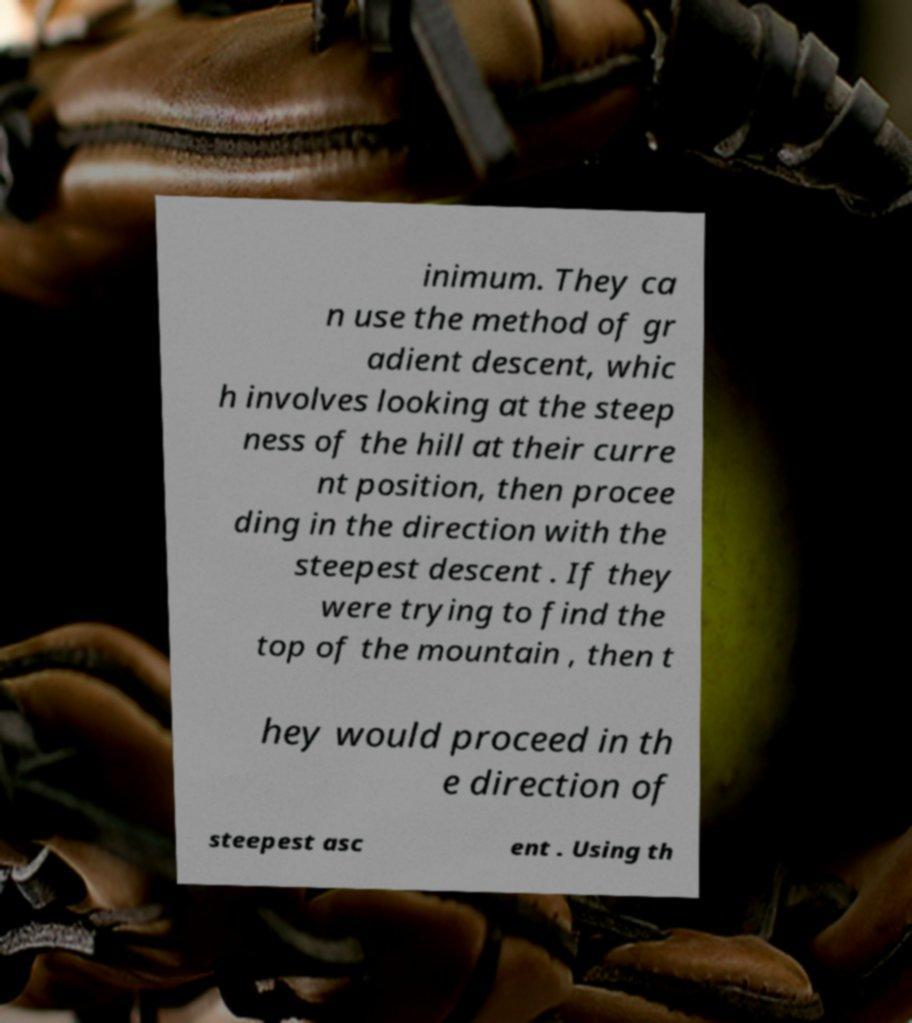Can you accurately transcribe the text from the provided image for me? inimum. They ca n use the method of gr adient descent, whic h involves looking at the steep ness of the hill at their curre nt position, then procee ding in the direction with the steepest descent . If they were trying to find the top of the mountain , then t hey would proceed in th e direction of steepest asc ent . Using th 